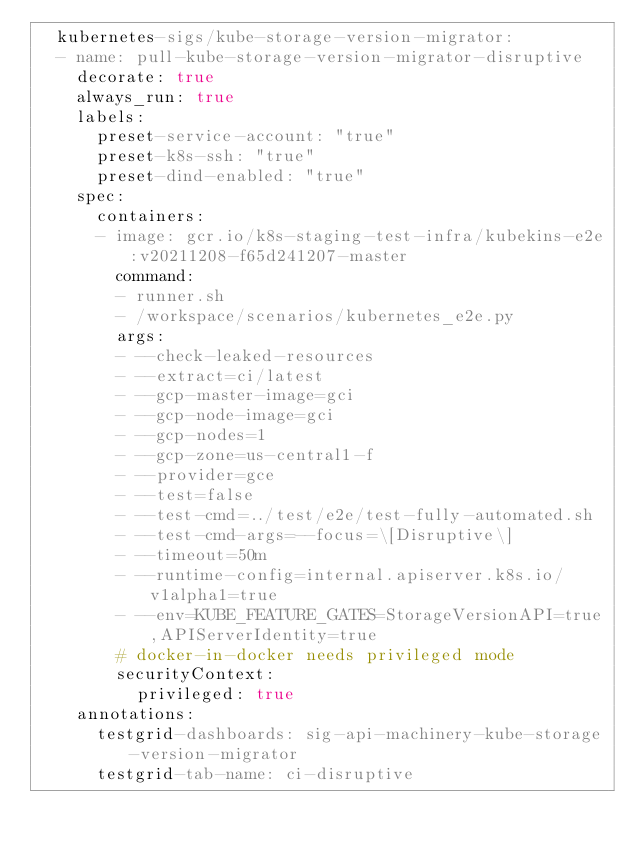Convert code to text. <code><loc_0><loc_0><loc_500><loc_500><_YAML_>  kubernetes-sigs/kube-storage-version-migrator:
  - name: pull-kube-storage-version-migrator-disruptive
    decorate: true
    always_run: true
    labels:
      preset-service-account: "true"
      preset-k8s-ssh: "true"
      preset-dind-enabled: "true"
    spec:
      containers:
      - image: gcr.io/k8s-staging-test-infra/kubekins-e2e:v20211208-f65d241207-master
        command:
        - runner.sh
        - /workspace/scenarios/kubernetes_e2e.py
        args:
        - --check-leaked-resources
        - --extract=ci/latest
        - --gcp-master-image=gci
        - --gcp-node-image=gci
        - --gcp-nodes=1
        - --gcp-zone=us-central1-f
        - --provider=gce
        - --test=false
        - --test-cmd=../test/e2e/test-fully-automated.sh
        - --test-cmd-args=--focus=\[Disruptive\]
        - --timeout=50m
        - --runtime-config=internal.apiserver.k8s.io/v1alpha1=true
        - --env=KUBE_FEATURE_GATES=StorageVersionAPI=true,APIServerIdentity=true
        # docker-in-docker needs privileged mode
        securityContext:
          privileged: true
    annotations:
      testgrid-dashboards: sig-api-machinery-kube-storage-version-migrator
      testgrid-tab-name: ci-disruptive
</code> 